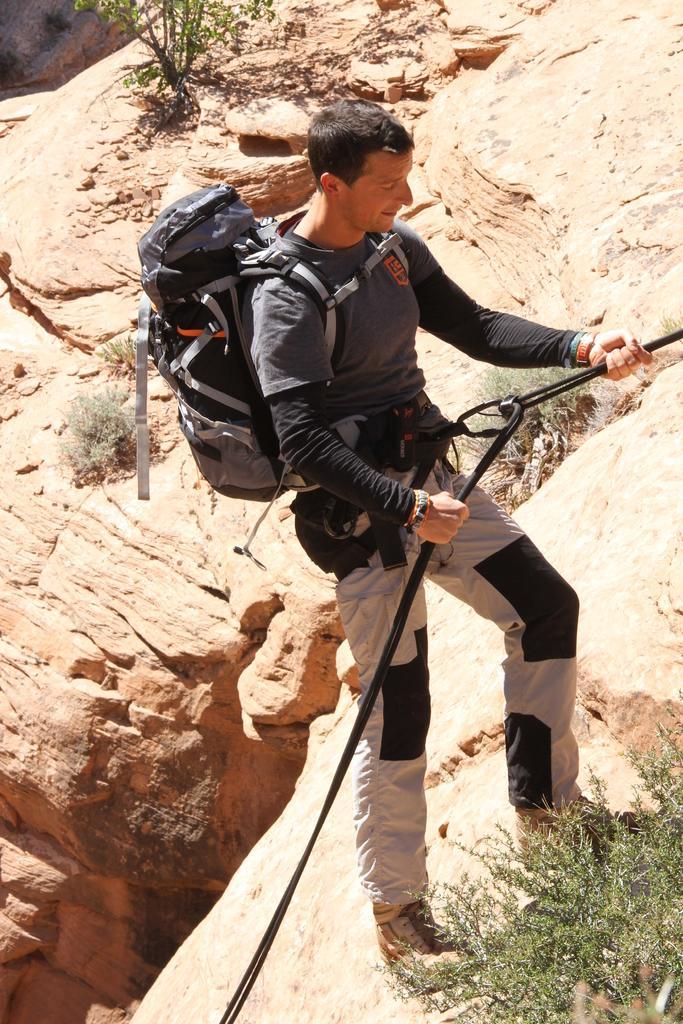Can you describe this image briefly? This image consists of a man climbing the mountain. He is wearing a backpack. At the bottom, we can see a small plant. In the background, there are mountains and rocks. 